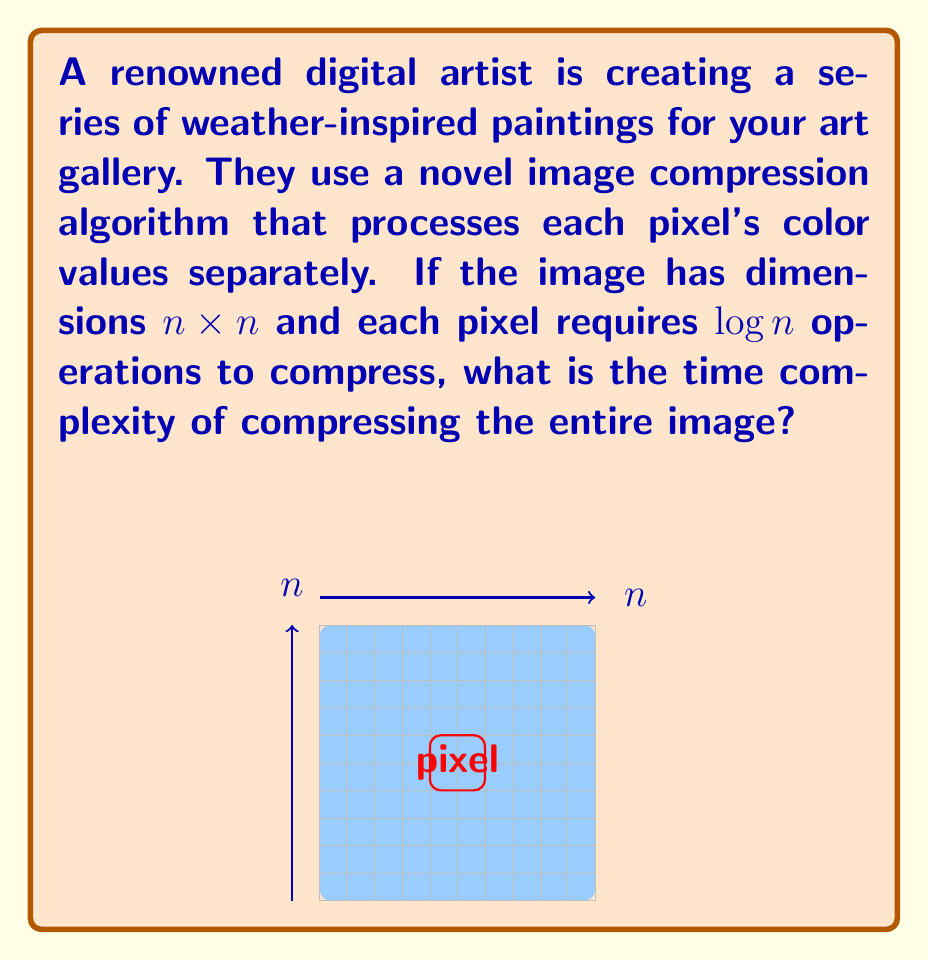What is the answer to this math problem? Let's approach this step-by-step:

1) First, we need to determine the total number of pixels in the image:
   - The image has dimensions $n \times n$
   - Total number of pixels = $n^2$

2) For each pixel, the algorithm performs $\log n$ operations:
   - Operations per pixel = $\log n$

3) To find the total number of operations, we multiply the number of pixels by the operations per pixel:
   - Total operations = $n^2 \times \log n$

4) In Big O notation, we express this as:
   $$O(n^2 \log n)$$

5) This is the time complexity of the algorithm. It's superlinear (grows faster than $n^2$) but subquadratic (grows slower than $n^3$).

The artist's weather-inspired paintings, when compressed using this algorithm, would require a time proportional to $n^2 \log n$, where $n$ is the width (or height) of the square canvas.
Answer: $O(n^2 \log n)$ 